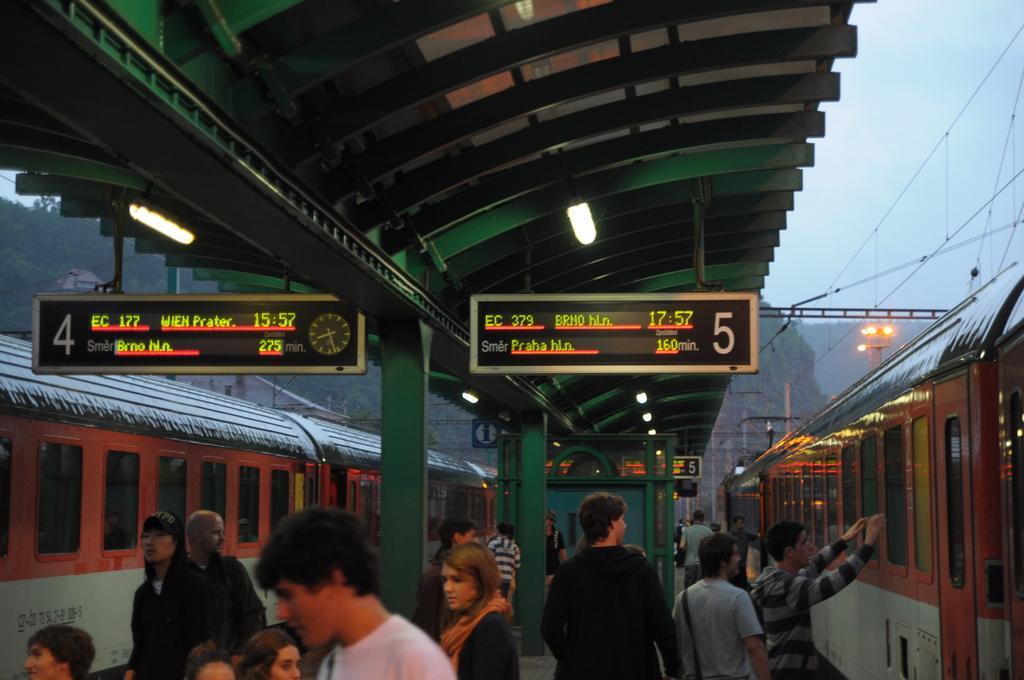What can be seen on the platform in the image? There are people standing on the platform in the image. What type of vehicles are present in the image? There are trains in the image. What structures are present in the image? Poles, boards, and a roof are visible in the image. What additional features can be seen in the image? Lights are present in the image. What is the background of the image like? There is a mountain in the background of the image, and the sky is visible as well. What type of oatmeal is being served on the platform in the image? There is no oatmeal present in the image; it features people standing on a platform with trains, poles, boards, a roof, lights, a mountain, and the sky visible in the background. How does the mist affect the visibility of the mountain in the image? There is no mist present in the image; the mountain and sky are clearly visible in the background. 